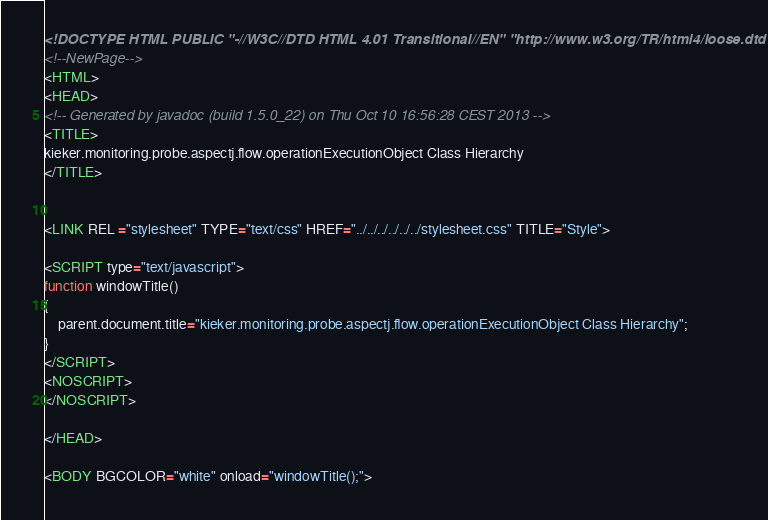Convert code to text. <code><loc_0><loc_0><loc_500><loc_500><_HTML_><!DOCTYPE HTML PUBLIC "-//W3C//DTD HTML 4.01 Transitional//EN" "http://www.w3.org/TR/html4/loose.dtd">
<!--NewPage-->
<HTML>
<HEAD>
<!-- Generated by javadoc (build 1.5.0_22) on Thu Oct 10 16:56:28 CEST 2013 -->
<TITLE>
kieker.monitoring.probe.aspectj.flow.operationExecutionObject Class Hierarchy
</TITLE>


<LINK REL ="stylesheet" TYPE="text/css" HREF="../../../../../../stylesheet.css" TITLE="Style">

<SCRIPT type="text/javascript">
function windowTitle()
{
    parent.document.title="kieker.monitoring.probe.aspectj.flow.operationExecutionObject Class Hierarchy";
}
</SCRIPT>
<NOSCRIPT>
</NOSCRIPT>

</HEAD>

<BODY BGCOLOR="white" onload="windowTitle();">

</code> 